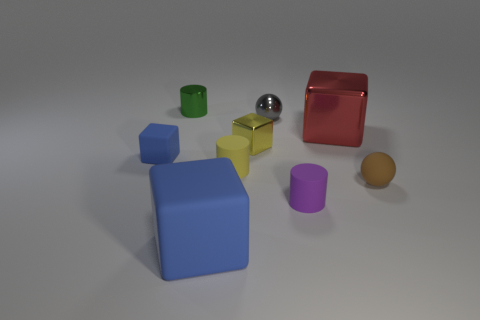Is there anything else that is the same size as the gray thing?
Your answer should be compact. Yes. There is a tiny block that is the same material as the large blue thing; what is its color?
Your answer should be very brief. Blue. There is a thing that is behind the large blue thing and in front of the tiny brown matte thing; how big is it?
Your answer should be very brief. Small. Are there fewer tiny blue cubes that are in front of the brown matte sphere than large blue blocks behind the yellow rubber cylinder?
Your response must be concise. No. Do the cylinder to the right of the tiny gray object and the sphere on the right side of the purple cylinder have the same material?
Keep it short and to the point. Yes. The object that is to the right of the tiny purple matte thing and in front of the red block has what shape?
Provide a short and direct response. Sphere. The blue cube behind the big block that is in front of the tiny blue rubber thing is made of what material?
Offer a very short reply. Rubber. Are there more red objects than tiny gray matte cubes?
Your response must be concise. Yes. Is the color of the small rubber cube the same as the large rubber thing?
Give a very brief answer. Yes. What material is the yellow cube that is the same size as the gray thing?
Offer a very short reply. Metal. 